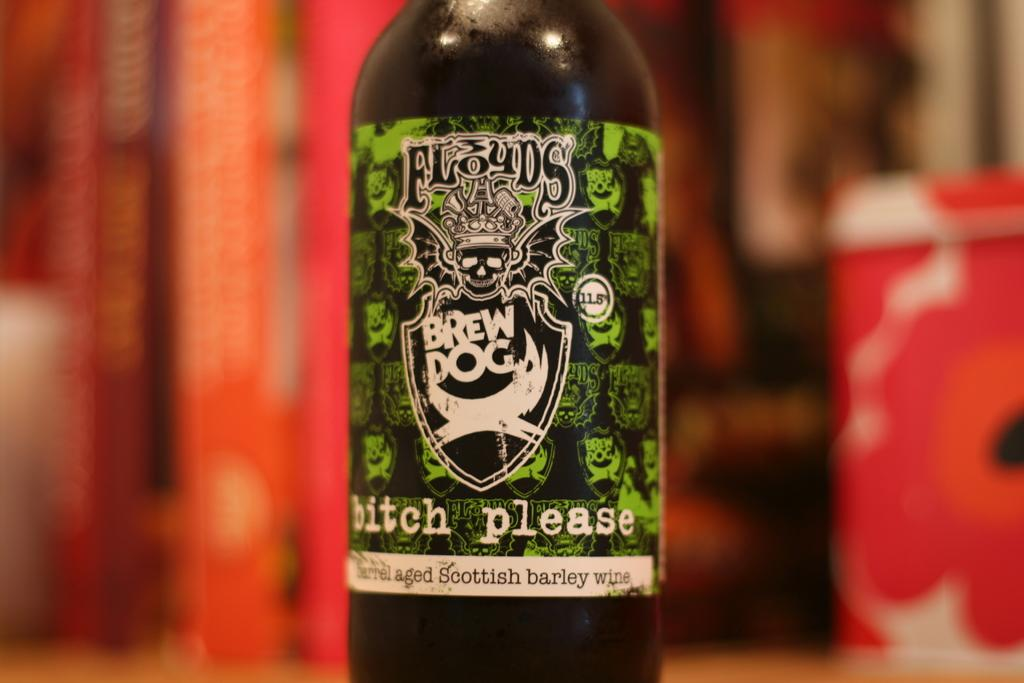<image>
Give a short and clear explanation of the subsequent image. A bottle of beer with a green and black label that has white writing and is called Brew Dog 